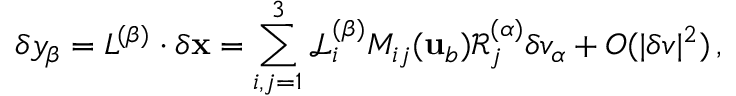Convert formula to latex. <formula><loc_0><loc_0><loc_500><loc_500>\delta y _ { \beta } = \mathbf c a l { L } ^ { ( \beta ) } \cdot \delta { x } = \sum _ { i , j = 1 } ^ { 3 } \mathcal { L } _ { i } ^ { ( \beta ) } M _ { i j } ( { u } _ { b } ) \mathcal { R } _ { j } ^ { ( \alpha ) } \delta v _ { \alpha } + O ( | \delta v | ^ { 2 } ) \, ,</formula> 